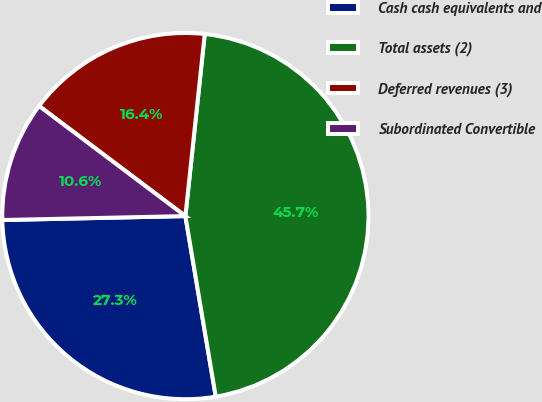<chart> <loc_0><loc_0><loc_500><loc_500><pie_chart><fcel>Cash cash equivalents and<fcel>Total assets (2)<fcel>Deferred revenues (3)<fcel>Subordinated Convertible<nl><fcel>27.31%<fcel>45.66%<fcel>16.42%<fcel>10.61%<nl></chart> 